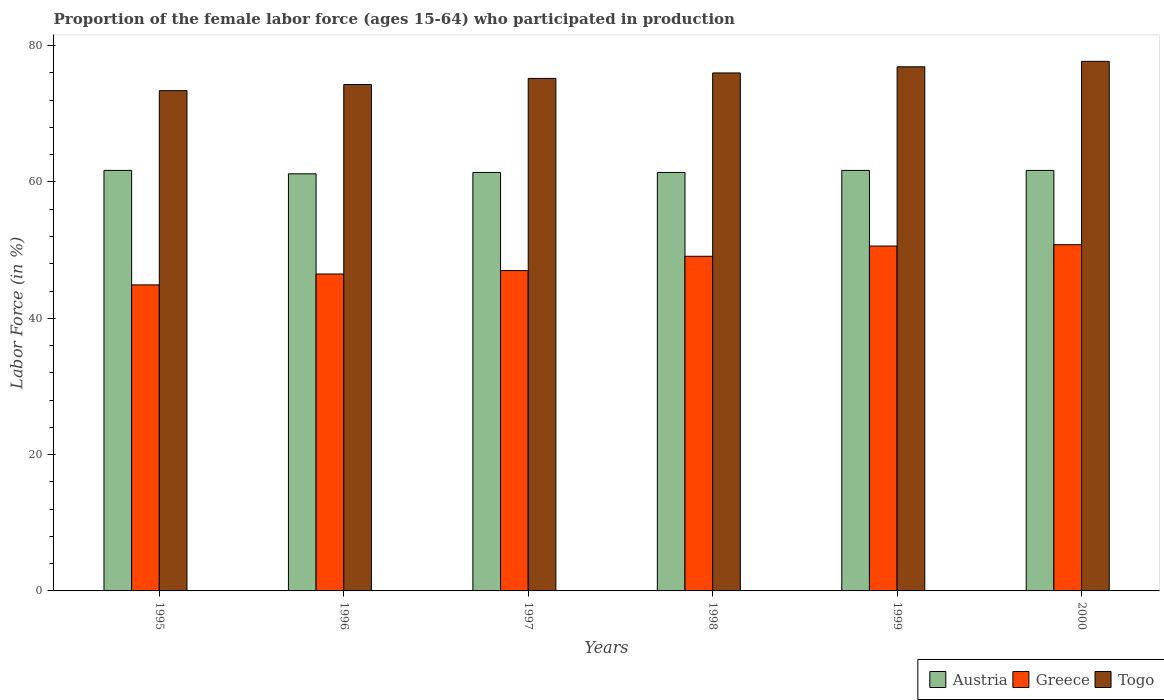How many different coloured bars are there?
Provide a succinct answer. 3. How many groups of bars are there?
Offer a very short reply. 6. Are the number of bars per tick equal to the number of legend labels?
Offer a terse response. Yes. How many bars are there on the 3rd tick from the left?
Keep it short and to the point. 3. How many bars are there on the 2nd tick from the right?
Offer a very short reply. 3. What is the proportion of the female labor force who participated in production in Togo in 1997?
Offer a terse response. 75.2. Across all years, what is the maximum proportion of the female labor force who participated in production in Greece?
Your response must be concise. 50.8. Across all years, what is the minimum proportion of the female labor force who participated in production in Togo?
Your response must be concise. 73.4. In which year was the proportion of the female labor force who participated in production in Togo minimum?
Offer a very short reply. 1995. What is the total proportion of the female labor force who participated in production in Togo in the graph?
Provide a succinct answer. 453.5. What is the difference between the proportion of the female labor force who participated in production in Greece in 1995 and that in 1998?
Ensure brevity in your answer.  -4.2. What is the difference between the proportion of the female labor force who participated in production in Togo in 1998 and the proportion of the female labor force who participated in production in Greece in 1995?
Make the answer very short. 31.1. What is the average proportion of the female labor force who participated in production in Greece per year?
Your answer should be compact. 48.15. In the year 1997, what is the difference between the proportion of the female labor force who participated in production in Togo and proportion of the female labor force who participated in production in Austria?
Your answer should be compact. 13.8. What is the ratio of the proportion of the female labor force who participated in production in Austria in 1998 to that in 1999?
Offer a terse response. 1. Is the proportion of the female labor force who participated in production in Togo in 1995 less than that in 1996?
Ensure brevity in your answer.  Yes. What is the difference between the highest and the second highest proportion of the female labor force who participated in production in Greece?
Your response must be concise. 0.2. What is the difference between the highest and the lowest proportion of the female labor force who participated in production in Togo?
Your response must be concise. 4.3. What does the 1st bar from the right in 1998 represents?
Your answer should be compact. Togo. How many bars are there?
Offer a terse response. 18. Are all the bars in the graph horizontal?
Your answer should be very brief. No. How many years are there in the graph?
Keep it short and to the point. 6. What is the difference between two consecutive major ticks on the Y-axis?
Provide a succinct answer. 20. Are the values on the major ticks of Y-axis written in scientific E-notation?
Your answer should be very brief. No. How many legend labels are there?
Provide a succinct answer. 3. How are the legend labels stacked?
Provide a short and direct response. Horizontal. What is the title of the graph?
Your answer should be very brief. Proportion of the female labor force (ages 15-64) who participated in production. What is the label or title of the X-axis?
Your answer should be very brief. Years. What is the Labor Force (in %) of Austria in 1995?
Make the answer very short. 61.7. What is the Labor Force (in %) of Greece in 1995?
Provide a succinct answer. 44.9. What is the Labor Force (in %) in Togo in 1995?
Offer a terse response. 73.4. What is the Labor Force (in %) of Austria in 1996?
Your response must be concise. 61.2. What is the Labor Force (in %) in Greece in 1996?
Ensure brevity in your answer.  46.5. What is the Labor Force (in %) of Togo in 1996?
Give a very brief answer. 74.3. What is the Labor Force (in %) of Austria in 1997?
Make the answer very short. 61.4. What is the Labor Force (in %) in Greece in 1997?
Make the answer very short. 47. What is the Labor Force (in %) in Togo in 1997?
Ensure brevity in your answer.  75.2. What is the Labor Force (in %) in Austria in 1998?
Make the answer very short. 61.4. What is the Labor Force (in %) in Greece in 1998?
Your answer should be very brief. 49.1. What is the Labor Force (in %) of Austria in 1999?
Provide a succinct answer. 61.7. What is the Labor Force (in %) in Greece in 1999?
Ensure brevity in your answer.  50.6. What is the Labor Force (in %) in Togo in 1999?
Make the answer very short. 76.9. What is the Labor Force (in %) in Austria in 2000?
Your answer should be compact. 61.7. What is the Labor Force (in %) in Greece in 2000?
Your answer should be compact. 50.8. What is the Labor Force (in %) in Togo in 2000?
Your answer should be compact. 77.7. Across all years, what is the maximum Labor Force (in %) in Austria?
Offer a very short reply. 61.7. Across all years, what is the maximum Labor Force (in %) in Greece?
Offer a terse response. 50.8. Across all years, what is the maximum Labor Force (in %) of Togo?
Keep it short and to the point. 77.7. Across all years, what is the minimum Labor Force (in %) of Austria?
Offer a terse response. 61.2. Across all years, what is the minimum Labor Force (in %) in Greece?
Your answer should be very brief. 44.9. Across all years, what is the minimum Labor Force (in %) of Togo?
Your answer should be very brief. 73.4. What is the total Labor Force (in %) in Austria in the graph?
Your answer should be very brief. 369.1. What is the total Labor Force (in %) of Greece in the graph?
Provide a short and direct response. 288.9. What is the total Labor Force (in %) of Togo in the graph?
Provide a succinct answer. 453.5. What is the difference between the Labor Force (in %) in Austria in 1995 and that in 1996?
Your answer should be very brief. 0.5. What is the difference between the Labor Force (in %) of Greece in 1995 and that in 1996?
Give a very brief answer. -1.6. What is the difference between the Labor Force (in %) of Greece in 1995 and that in 1997?
Give a very brief answer. -2.1. What is the difference between the Labor Force (in %) in Togo in 1995 and that in 1998?
Make the answer very short. -2.6. What is the difference between the Labor Force (in %) of Togo in 1995 and that in 1999?
Your answer should be very brief. -3.5. What is the difference between the Labor Force (in %) of Togo in 1996 and that in 1997?
Keep it short and to the point. -0.9. What is the difference between the Labor Force (in %) of Greece in 1996 and that in 1998?
Keep it short and to the point. -2.6. What is the difference between the Labor Force (in %) of Austria in 1996 and that in 1999?
Provide a short and direct response. -0.5. What is the difference between the Labor Force (in %) in Greece in 1996 and that in 2000?
Provide a succinct answer. -4.3. What is the difference between the Labor Force (in %) in Austria in 1997 and that in 1998?
Your answer should be compact. 0. What is the difference between the Labor Force (in %) of Greece in 1997 and that in 1998?
Your response must be concise. -2.1. What is the difference between the Labor Force (in %) in Togo in 1997 and that in 1999?
Give a very brief answer. -1.7. What is the difference between the Labor Force (in %) in Austria in 1998 and that in 1999?
Your answer should be very brief. -0.3. What is the difference between the Labor Force (in %) of Austria in 1998 and that in 2000?
Offer a very short reply. -0.3. What is the difference between the Labor Force (in %) in Togo in 1998 and that in 2000?
Offer a very short reply. -1.7. What is the difference between the Labor Force (in %) of Togo in 1999 and that in 2000?
Your answer should be compact. -0.8. What is the difference between the Labor Force (in %) in Austria in 1995 and the Labor Force (in %) in Greece in 1996?
Offer a very short reply. 15.2. What is the difference between the Labor Force (in %) in Greece in 1995 and the Labor Force (in %) in Togo in 1996?
Make the answer very short. -29.4. What is the difference between the Labor Force (in %) of Austria in 1995 and the Labor Force (in %) of Greece in 1997?
Provide a short and direct response. 14.7. What is the difference between the Labor Force (in %) in Greece in 1995 and the Labor Force (in %) in Togo in 1997?
Your answer should be very brief. -30.3. What is the difference between the Labor Force (in %) in Austria in 1995 and the Labor Force (in %) in Greece in 1998?
Your answer should be compact. 12.6. What is the difference between the Labor Force (in %) in Austria in 1995 and the Labor Force (in %) in Togo in 1998?
Keep it short and to the point. -14.3. What is the difference between the Labor Force (in %) in Greece in 1995 and the Labor Force (in %) in Togo in 1998?
Your answer should be compact. -31.1. What is the difference between the Labor Force (in %) of Austria in 1995 and the Labor Force (in %) of Togo in 1999?
Ensure brevity in your answer.  -15.2. What is the difference between the Labor Force (in %) in Greece in 1995 and the Labor Force (in %) in Togo in 1999?
Your answer should be very brief. -32. What is the difference between the Labor Force (in %) in Austria in 1995 and the Labor Force (in %) in Greece in 2000?
Keep it short and to the point. 10.9. What is the difference between the Labor Force (in %) in Austria in 1995 and the Labor Force (in %) in Togo in 2000?
Provide a short and direct response. -16. What is the difference between the Labor Force (in %) in Greece in 1995 and the Labor Force (in %) in Togo in 2000?
Your answer should be compact. -32.8. What is the difference between the Labor Force (in %) in Austria in 1996 and the Labor Force (in %) in Greece in 1997?
Provide a short and direct response. 14.2. What is the difference between the Labor Force (in %) in Austria in 1996 and the Labor Force (in %) in Togo in 1997?
Your answer should be compact. -14. What is the difference between the Labor Force (in %) of Greece in 1996 and the Labor Force (in %) of Togo in 1997?
Make the answer very short. -28.7. What is the difference between the Labor Force (in %) of Austria in 1996 and the Labor Force (in %) of Greece in 1998?
Ensure brevity in your answer.  12.1. What is the difference between the Labor Force (in %) in Austria in 1996 and the Labor Force (in %) in Togo in 1998?
Provide a short and direct response. -14.8. What is the difference between the Labor Force (in %) in Greece in 1996 and the Labor Force (in %) in Togo in 1998?
Your answer should be compact. -29.5. What is the difference between the Labor Force (in %) in Austria in 1996 and the Labor Force (in %) in Greece in 1999?
Your answer should be very brief. 10.6. What is the difference between the Labor Force (in %) of Austria in 1996 and the Labor Force (in %) of Togo in 1999?
Offer a terse response. -15.7. What is the difference between the Labor Force (in %) in Greece in 1996 and the Labor Force (in %) in Togo in 1999?
Give a very brief answer. -30.4. What is the difference between the Labor Force (in %) in Austria in 1996 and the Labor Force (in %) in Greece in 2000?
Give a very brief answer. 10.4. What is the difference between the Labor Force (in %) of Austria in 1996 and the Labor Force (in %) of Togo in 2000?
Your response must be concise. -16.5. What is the difference between the Labor Force (in %) in Greece in 1996 and the Labor Force (in %) in Togo in 2000?
Offer a terse response. -31.2. What is the difference between the Labor Force (in %) in Austria in 1997 and the Labor Force (in %) in Greece in 1998?
Provide a succinct answer. 12.3. What is the difference between the Labor Force (in %) of Austria in 1997 and the Labor Force (in %) of Togo in 1998?
Make the answer very short. -14.6. What is the difference between the Labor Force (in %) in Greece in 1997 and the Labor Force (in %) in Togo in 1998?
Offer a terse response. -29. What is the difference between the Labor Force (in %) in Austria in 1997 and the Labor Force (in %) in Togo in 1999?
Give a very brief answer. -15.5. What is the difference between the Labor Force (in %) in Greece in 1997 and the Labor Force (in %) in Togo in 1999?
Keep it short and to the point. -29.9. What is the difference between the Labor Force (in %) of Austria in 1997 and the Labor Force (in %) of Togo in 2000?
Provide a succinct answer. -16.3. What is the difference between the Labor Force (in %) of Greece in 1997 and the Labor Force (in %) of Togo in 2000?
Provide a succinct answer. -30.7. What is the difference between the Labor Force (in %) of Austria in 1998 and the Labor Force (in %) of Greece in 1999?
Give a very brief answer. 10.8. What is the difference between the Labor Force (in %) in Austria in 1998 and the Labor Force (in %) in Togo in 1999?
Offer a very short reply. -15.5. What is the difference between the Labor Force (in %) in Greece in 1998 and the Labor Force (in %) in Togo in 1999?
Keep it short and to the point. -27.8. What is the difference between the Labor Force (in %) of Austria in 1998 and the Labor Force (in %) of Togo in 2000?
Provide a short and direct response. -16.3. What is the difference between the Labor Force (in %) of Greece in 1998 and the Labor Force (in %) of Togo in 2000?
Your answer should be compact. -28.6. What is the difference between the Labor Force (in %) of Austria in 1999 and the Labor Force (in %) of Greece in 2000?
Provide a succinct answer. 10.9. What is the difference between the Labor Force (in %) of Greece in 1999 and the Labor Force (in %) of Togo in 2000?
Your answer should be compact. -27.1. What is the average Labor Force (in %) of Austria per year?
Ensure brevity in your answer.  61.52. What is the average Labor Force (in %) in Greece per year?
Ensure brevity in your answer.  48.15. What is the average Labor Force (in %) in Togo per year?
Offer a terse response. 75.58. In the year 1995, what is the difference between the Labor Force (in %) of Austria and Labor Force (in %) of Greece?
Your answer should be very brief. 16.8. In the year 1995, what is the difference between the Labor Force (in %) in Austria and Labor Force (in %) in Togo?
Ensure brevity in your answer.  -11.7. In the year 1995, what is the difference between the Labor Force (in %) of Greece and Labor Force (in %) of Togo?
Ensure brevity in your answer.  -28.5. In the year 1996, what is the difference between the Labor Force (in %) of Austria and Labor Force (in %) of Greece?
Offer a very short reply. 14.7. In the year 1996, what is the difference between the Labor Force (in %) in Austria and Labor Force (in %) in Togo?
Keep it short and to the point. -13.1. In the year 1996, what is the difference between the Labor Force (in %) of Greece and Labor Force (in %) of Togo?
Give a very brief answer. -27.8. In the year 1997, what is the difference between the Labor Force (in %) of Austria and Labor Force (in %) of Togo?
Provide a succinct answer. -13.8. In the year 1997, what is the difference between the Labor Force (in %) of Greece and Labor Force (in %) of Togo?
Your answer should be compact. -28.2. In the year 1998, what is the difference between the Labor Force (in %) in Austria and Labor Force (in %) in Greece?
Provide a short and direct response. 12.3. In the year 1998, what is the difference between the Labor Force (in %) of Austria and Labor Force (in %) of Togo?
Keep it short and to the point. -14.6. In the year 1998, what is the difference between the Labor Force (in %) in Greece and Labor Force (in %) in Togo?
Give a very brief answer. -26.9. In the year 1999, what is the difference between the Labor Force (in %) in Austria and Labor Force (in %) in Greece?
Your answer should be compact. 11.1. In the year 1999, what is the difference between the Labor Force (in %) in Austria and Labor Force (in %) in Togo?
Provide a succinct answer. -15.2. In the year 1999, what is the difference between the Labor Force (in %) of Greece and Labor Force (in %) of Togo?
Your answer should be compact. -26.3. In the year 2000, what is the difference between the Labor Force (in %) in Austria and Labor Force (in %) in Greece?
Your answer should be compact. 10.9. In the year 2000, what is the difference between the Labor Force (in %) of Austria and Labor Force (in %) of Togo?
Ensure brevity in your answer.  -16. In the year 2000, what is the difference between the Labor Force (in %) of Greece and Labor Force (in %) of Togo?
Give a very brief answer. -26.9. What is the ratio of the Labor Force (in %) in Austria in 1995 to that in 1996?
Provide a short and direct response. 1.01. What is the ratio of the Labor Force (in %) of Greece in 1995 to that in 1996?
Keep it short and to the point. 0.97. What is the ratio of the Labor Force (in %) in Togo in 1995 to that in 1996?
Your response must be concise. 0.99. What is the ratio of the Labor Force (in %) in Austria in 1995 to that in 1997?
Ensure brevity in your answer.  1. What is the ratio of the Labor Force (in %) in Greece in 1995 to that in 1997?
Give a very brief answer. 0.96. What is the ratio of the Labor Force (in %) in Togo in 1995 to that in 1997?
Your response must be concise. 0.98. What is the ratio of the Labor Force (in %) of Austria in 1995 to that in 1998?
Ensure brevity in your answer.  1. What is the ratio of the Labor Force (in %) in Greece in 1995 to that in 1998?
Keep it short and to the point. 0.91. What is the ratio of the Labor Force (in %) in Togo in 1995 to that in 1998?
Give a very brief answer. 0.97. What is the ratio of the Labor Force (in %) in Austria in 1995 to that in 1999?
Keep it short and to the point. 1. What is the ratio of the Labor Force (in %) in Greece in 1995 to that in 1999?
Your answer should be compact. 0.89. What is the ratio of the Labor Force (in %) of Togo in 1995 to that in 1999?
Your answer should be compact. 0.95. What is the ratio of the Labor Force (in %) in Austria in 1995 to that in 2000?
Keep it short and to the point. 1. What is the ratio of the Labor Force (in %) of Greece in 1995 to that in 2000?
Offer a terse response. 0.88. What is the ratio of the Labor Force (in %) in Togo in 1995 to that in 2000?
Keep it short and to the point. 0.94. What is the ratio of the Labor Force (in %) in Togo in 1996 to that in 1997?
Keep it short and to the point. 0.99. What is the ratio of the Labor Force (in %) in Austria in 1996 to that in 1998?
Provide a short and direct response. 1. What is the ratio of the Labor Force (in %) in Greece in 1996 to that in 1998?
Ensure brevity in your answer.  0.95. What is the ratio of the Labor Force (in %) of Togo in 1996 to that in 1998?
Give a very brief answer. 0.98. What is the ratio of the Labor Force (in %) of Austria in 1996 to that in 1999?
Ensure brevity in your answer.  0.99. What is the ratio of the Labor Force (in %) of Greece in 1996 to that in 1999?
Offer a very short reply. 0.92. What is the ratio of the Labor Force (in %) of Togo in 1996 to that in 1999?
Offer a very short reply. 0.97. What is the ratio of the Labor Force (in %) in Austria in 1996 to that in 2000?
Offer a very short reply. 0.99. What is the ratio of the Labor Force (in %) in Greece in 1996 to that in 2000?
Ensure brevity in your answer.  0.92. What is the ratio of the Labor Force (in %) of Togo in 1996 to that in 2000?
Make the answer very short. 0.96. What is the ratio of the Labor Force (in %) of Greece in 1997 to that in 1998?
Your response must be concise. 0.96. What is the ratio of the Labor Force (in %) in Greece in 1997 to that in 1999?
Keep it short and to the point. 0.93. What is the ratio of the Labor Force (in %) of Togo in 1997 to that in 1999?
Your answer should be compact. 0.98. What is the ratio of the Labor Force (in %) in Austria in 1997 to that in 2000?
Your answer should be very brief. 1. What is the ratio of the Labor Force (in %) of Greece in 1997 to that in 2000?
Provide a short and direct response. 0.93. What is the ratio of the Labor Force (in %) of Togo in 1997 to that in 2000?
Your answer should be very brief. 0.97. What is the ratio of the Labor Force (in %) of Austria in 1998 to that in 1999?
Your response must be concise. 1. What is the ratio of the Labor Force (in %) of Greece in 1998 to that in 1999?
Your answer should be compact. 0.97. What is the ratio of the Labor Force (in %) in Togo in 1998 to that in 1999?
Your answer should be compact. 0.99. What is the ratio of the Labor Force (in %) in Austria in 1998 to that in 2000?
Provide a succinct answer. 1. What is the ratio of the Labor Force (in %) in Greece in 1998 to that in 2000?
Offer a very short reply. 0.97. What is the ratio of the Labor Force (in %) in Togo in 1998 to that in 2000?
Give a very brief answer. 0.98. What is the ratio of the Labor Force (in %) in Austria in 1999 to that in 2000?
Offer a terse response. 1. What is the ratio of the Labor Force (in %) in Greece in 1999 to that in 2000?
Give a very brief answer. 1. What is the difference between the highest and the second highest Labor Force (in %) of Greece?
Offer a very short reply. 0.2. 